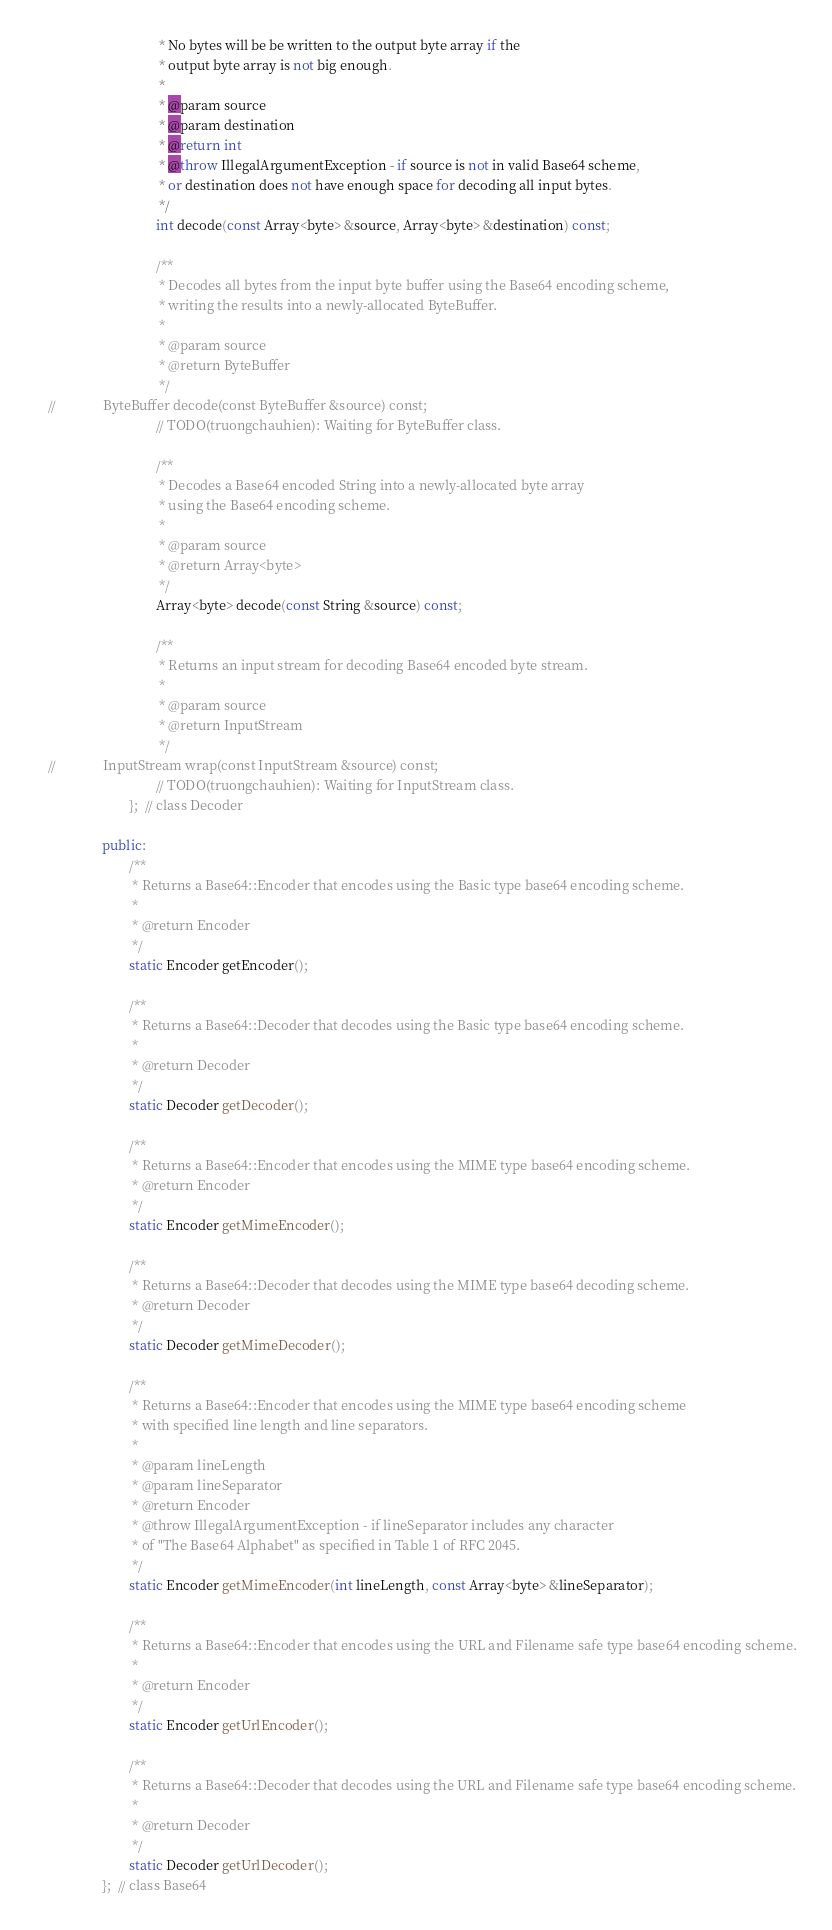Convert code to text. <code><loc_0><loc_0><loc_500><loc_500><_C++_>								 * No bytes will be be written to the output byte array if the
								 * output byte array is not big enough.
								 *
								 * @param source
								 * @param destination
								 * @return int
								 * @throw IllegalArgumentException - if source is not in valid Base64 scheme,
								 * or destination does not have enough space for decoding all input bytes.
								 */
								int decode(const Array<byte> &source, Array<byte> &destination) const;
								
								/**
								 * Decodes all bytes from the input byte buffer using the Base64 encoding scheme,
								 * writing the results into a newly-allocated ByteBuffer.
								 *
								 * @param source
								 * @return ByteBuffer
								 */
//              ByteBuffer decode(const ByteBuffer &source) const;
								// TODO(truongchauhien): Waiting for ByteBuffer class.
								
								/**
								 * Decodes a Base64 encoded String into a newly-allocated byte array
								 * using the Base64 encoding scheme.
								 *
								 * @param source
								 * @return Array<byte>
								 */
								Array<byte> decode(const String &source) const;
								
								/**
								 * Returns an input stream for decoding Base64 encoded byte stream.
								 *
								 * @param source
								 * @return InputStream
								 */
//              InputStream wrap(const InputStream &source) const;
								// TODO(truongchauhien): Waiting for InputStream class.
						};  // class Decoder
				
				public:
						/**
						 * Returns a Base64::Encoder that encodes using the Basic type base64 encoding scheme.
						 *
						 * @return Encoder
						 */
						static Encoder getEncoder();
						
						/**
						 * Returns a Base64::Decoder that decodes using the Basic type base64 encoding scheme.
						 *
						 * @return Decoder
						 */
						static Decoder getDecoder();
						
						/**
						 * Returns a Base64::Encoder that encodes using the MIME type base64 encoding scheme.
						 * @return Encoder
						 */
						static Encoder getMimeEncoder();
						
						/**
						 * Returns a Base64::Decoder that decodes using the MIME type base64 decoding scheme.
						 * @return Decoder
						 */
						static Decoder getMimeDecoder();
						
						/**
						 * Returns a Base64::Encoder that encodes using the MIME type base64 encoding scheme
						 * with specified line length and line separators.
						 *
						 * @param lineLength
						 * @param lineSeparator
						 * @return Encoder
						 * @throw IllegalArgumentException - if lineSeparator includes any character
						 * of "The Base64 Alphabet" as specified in Table 1 of RFC 2045.
						 */
						static Encoder getMimeEncoder(int lineLength, const Array<byte> &lineSeparator);
						
						/**
						 * Returns a Base64::Encoder that encodes using the URL and Filename safe type base64 encoding scheme.
						 *
						 * @return Encoder
						 */
						static Encoder getUrlEncoder();
						
						/**
						 * Returns a Base64::Decoder that decodes using the URL and Filename safe type base64 encoding scheme.
						 *
						 * @return Decoder
						 */
						static Decoder getUrlDecoder();
				};  // class Base64</code> 